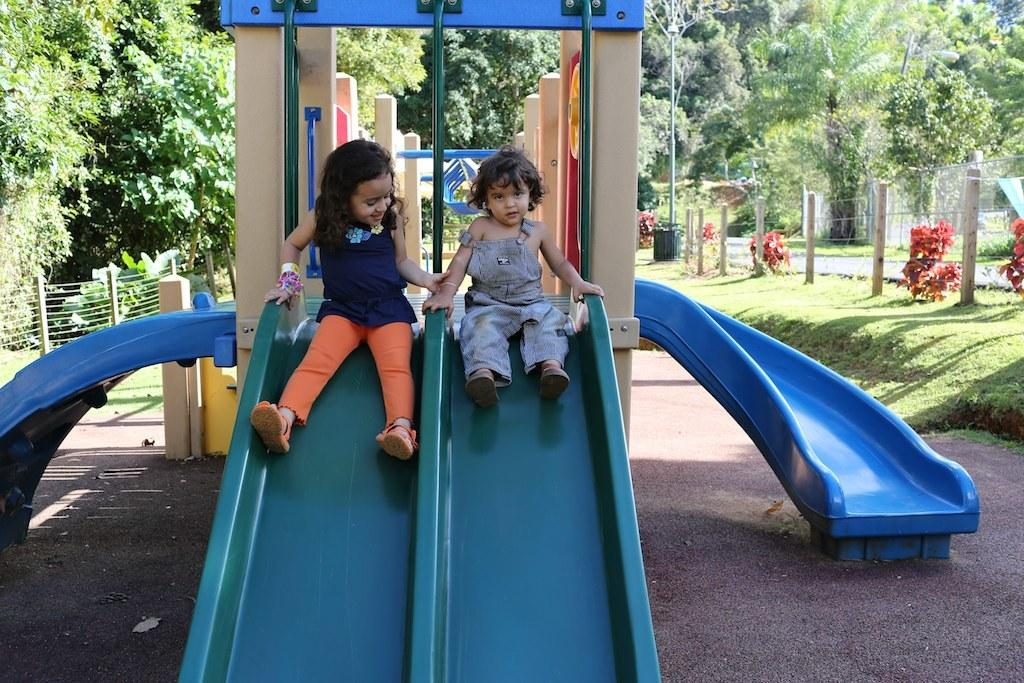How many girls are in the image? There are two small girls in the image. What are the girls doing in the image? The girls are sitting on a blue slide and smiling. What can be seen in the background of the image? There is a fencing grill and huge trees visible in the background. What type of chain is holding the girls on the slide in the image? There is no chain visible in the image; the girls are sitting on a blue slide without any visible chains. 